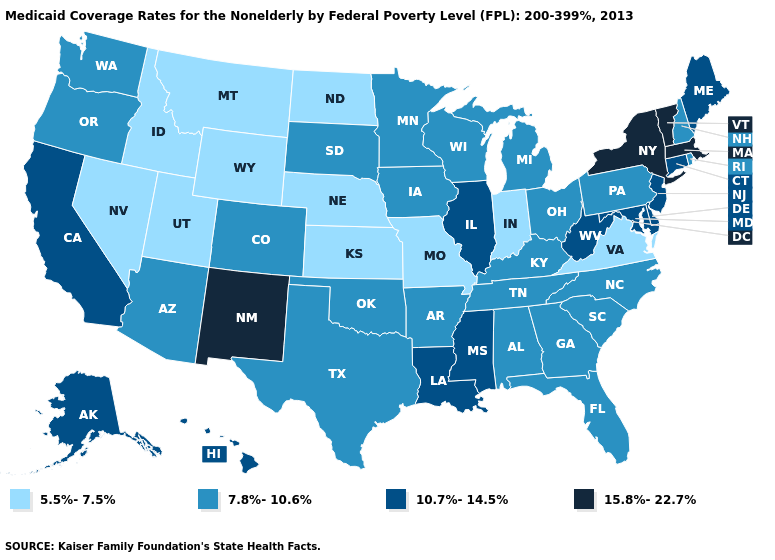Does Maryland have a lower value than Idaho?
Be succinct. No. Does the first symbol in the legend represent the smallest category?
Answer briefly. Yes. What is the value of Wyoming?
Give a very brief answer. 5.5%-7.5%. Does New York have the same value as Arkansas?
Quick response, please. No. Name the states that have a value in the range 15.8%-22.7%?
Answer briefly. Massachusetts, New Mexico, New York, Vermont. What is the value of Wisconsin?
Keep it brief. 7.8%-10.6%. Name the states that have a value in the range 10.7%-14.5%?
Give a very brief answer. Alaska, California, Connecticut, Delaware, Hawaii, Illinois, Louisiana, Maine, Maryland, Mississippi, New Jersey, West Virginia. What is the value of New York?
Quick response, please. 15.8%-22.7%. Does the map have missing data?
Be succinct. No. What is the value of North Carolina?
Quick response, please. 7.8%-10.6%. Which states have the lowest value in the South?
Short answer required. Virginia. What is the highest value in the USA?
Be succinct. 15.8%-22.7%. Does Kansas have a higher value than New York?
Answer briefly. No. Is the legend a continuous bar?
Quick response, please. No. What is the lowest value in the USA?
Answer briefly. 5.5%-7.5%. 